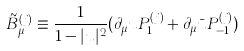<formula> <loc_0><loc_0><loc_500><loc_500>\tilde { B } _ { \mu } ^ { ( j ) } \equiv \frac { 1 } { 1 - | u | ^ { 2 } } ( \partial _ { \mu } u P _ { 1 } ^ { ( j ) } + \partial _ { \mu } \bar { u } P _ { - 1 } ^ { ( j ) } )</formula> 